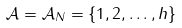Convert formula to latex. <formula><loc_0><loc_0><loc_500><loc_500>\mathcal { A } = \mathcal { A } _ { N } = \{ 1 , 2 , \dots , h \}</formula> 